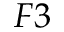Convert formula to latex. <formula><loc_0><loc_0><loc_500><loc_500>F 3</formula> 